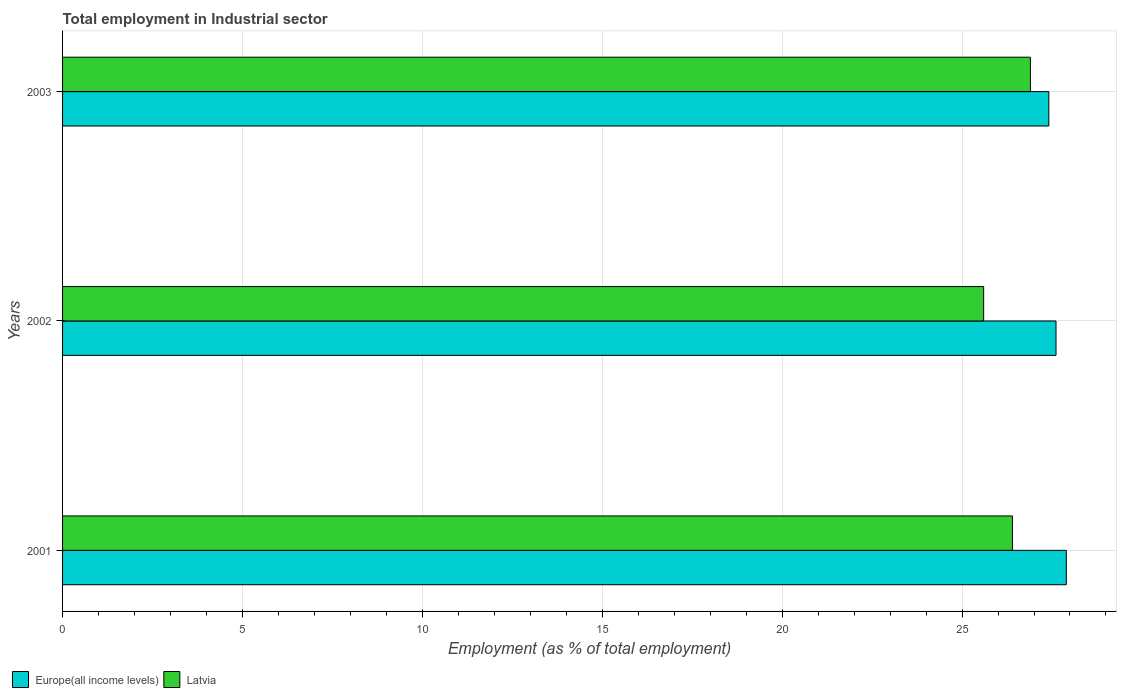How many different coloured bars are there?
Offer a terse response. 2. How many bars are there on the 1st tick from the top?
Make the answer very short. 2. How many bars are there on the 1st tick from the bottom?
Provide a short and direct response. 2. What is the label of the 1st group of bars from the top?
Offer a very short reply. 2003. What is the employment in industrial sector in Europe(all income levels) in 2003?
Your response must be concise. 27.41. Across all years, what is the maximum employment in industrial sector in Latvia?
Your answer should be compact. 26.9. Across all years, what is the minimum employment in industrial sector in Europe(all income levels)?
Provide a short and direct response. 27.41. In which year was the employment in industrial sector in Europe(all income levels) maximum?
Your answer should be very brief. 2001. In which year was the employment in industrial sector in Europe(all income levels) minimum?
Offer a very short reply. 2003. What is the total employment in industrial sector in Latvia in the graph?
Provide a succinct answer. 78.9. What is the difference between the employment in industrial sector in Latvia in 2001 and that in 2002?
Your answer should be very brief. 0.8. What is the difference between the employment in industrial sector in Europe(all income levels) in 2001 and the employment in industrial sector in Latvia in 2003?
Offer a very short reply. 1. What is the average employment in industrial sector in Europe(all income levels) per year?
Your answer should be compact. 27.64. In the year 2001, what is the difference between the employment in industrial sector in Europe(all income levels) and employment in industrial sector in Latvia?
Your answer should be compact. 1.5. What is the ratio of the employment in industrial sector in Europe(all income levels) in 2001 to that in 2003?
Give a very brief answer. 1.02. Is the difference between the employment in industrial sector in Europe(all income levels) in 2001 and 2002 greater than the difference between the employment in industrial sector in Latvia in 2001 and 2002?
Your answer should be compact. No. What is the difference between the highest and the lowest employment in industrial sector in Europe(all income levels)?
Offer a very short reply. 0.49. In how many years, is the employment in industrial sector in Europe(all income levels) greater than the average employment in industrial sector in Europe(all income levels) taken over all years?
Offer a very short reply. 1. What does the 2nd bar from the top in 2002 represents?
Provide a short and direct response. Europe(all income levels). What does the 2nd bar from the bottom in 2003 represents?
Offer a terse response. Latvia. How many bars are there?
Provide a succinct answer. 6. How many years are there in the graph?
Make the answer very short. 3. What is the difference between two consecutive major ticks on the X-axis?
Offer a very short reply. 5. Does the graph contain grids?
Offer a very short reply. Yes. Where does the legend appear in the graph?
Keep it short and to the point. Bottom left. How are the legend labels stacked?
Keep it short and to the point. Horizontal. What is the title of the graph?
Your response must be concise. Total employment in Industrial sector. Does "Yemen, Rep." appear as one of the legend labels in the graph?
Offer a terse response. No. What is the label or title of the X-axis?
Your answer should be very brief. Employment (as % of total employment). What is the label or title of the Y-axis?
Offer a very short reply. Years. What is the Employment (as % of total employment) in Europe(all income levels) in 2001?
Keep it short and to the point. 27.9. What is the Employment (as % of total employment) of Latvia in 2001?
Provide a short and direct response. 26.4. What is the Employment (as % of total employment) of Europe(all income levels) in 2002?
Your answer should be very brief. 27.61. What is the Employment (as % of total employment) of Latvia in 2002?
Your answer should be compact. 25.6. What is the Employment (as % of total employment) of Europe(all income levels) in 2003?
Your answer should be compact. 27.41. What is the Employment (as % of total employment) of Latvia in 2003?
Offer a very short reply. 26.9. Across all years, what is the maximum Employment (as % of total employment) in Europe(all income levels)?
Provide a succinct answer. 27.9. Across all years, what is the maximum Employment (as % of total employment) of Latvia?
Provide a short and direct response. 26.9. Across all years, what is the minimum Employment (as % of total employment) of Europe(all income levels)?
Keep it short and to the point. 27.41. Across all years, what is the minimum Employment (as % of total employment) of Latvia?
Give a very brief answer. 25.6. What is the total Employment (as % of total employment) in Europe(all income levels) in the graph?
Keep it short and to the point. 82.92. What is the total Employment (as % of total employment) in Latvia in the graph?
Ensure brevity in your answer.  78.9. What is the difference between the Employment (as % of total employment) of Europe(all income levels) in 2001 and that in 2002?
Keep it short and to the point. 0.29. What is the difference between the Employment (as % of total employment) in Europe(all income levels) in 2001 and that in 2003?
Provide a short and direct response. 0.49. What is the difference between the Employment (as % of total employment) in Latvia in 2001 and that in 2003?
Give a very brief answer. -0.5. What is the difference between the Employment (as % of total employment) in Europe(all income levels) in 2002 and that in 2003?
Provide a short and direct response. 0.2. What is the difference between the Employment (as % of total employment) of Europe(all income levels) in 2001 and the Employment (as % of total employment) of Latvia in 2002?
Your answer should be compact. 2.3. What is the difference between the Employment (as % of total employment) of Europe(all income levels) in 2002 and the Employment (as % of total employment) of Latvia in 2003?
Offer a very short reply. 0.71. What is the average Employment (as % of total employment) of Europe(all income levels) per year?
Give a very brief answer. 27.64. What is the average Employment (as % of total employment) of Latvia per year?
Provide a short and direct response. 26.3. In the year 2001, what is the difference between the Employment (as % of total employment) in Europe(all income levels) and Employment (as % of total employment) in Latvia?
Offer a terse response. 1.5. In the year 2002, what is the difference between the Employment (as % of total employment) in Europe(all income levels) and Employment (as % of total employment) in Latvia?
Offer a terse response. 2.01. In the year 2003, what is the difference between the Employment (as % of total employment) of Europe(all income levels) and Employment (as % of total employment) of Latvia?
Your response must be concise. 0.51. What is the ratio of the Employment (as % of total employment) in Europe(all income levels) in 2001 to that in 2002?
Offer a very short reply. 1.01. What is the ratio of the Employment (as % of total employment) of Latvia in 2001 to that in 2002?
Offer a terse response. 1.03. What is the ratio of the Employment (as % of total employment) of Europe(all income levels) in 2001 to that in 2003?
Provide a succinct answer. 1.02. What is the ratio of the Employment (as % of total employment) of Latvia in 2001 to that in 2003?
Make the answer very short. 0.98. What is the ratio of the Employment (as % of total employment) in Europe(all income levels) in 2002 to that in 2003?
Your response must be concise. 1.01. What is the ratio of the Employment (as % of total employment) in Latvia in 2002 to that in 2003?
Provide a short and direct response. 0.95. What is the difference between the highest and the second highest Employment (as % of total employment) of Europe(all income levels)?
Provide a short and direct response. 0.29. What is the difference between the highest and the second highest Employment (as % of total employment) of Latvia?
Provide a short and direct response. 0.5. What is the difference between the highest and the lowest Employment (as % of total employment) in Europe(all income levels)?
Make the answer very short. 0.49. What is the difference between the highest and the lowest Employment (as % of total employment) in Latvia?
Ensure brevity in your answer.  1.3. 